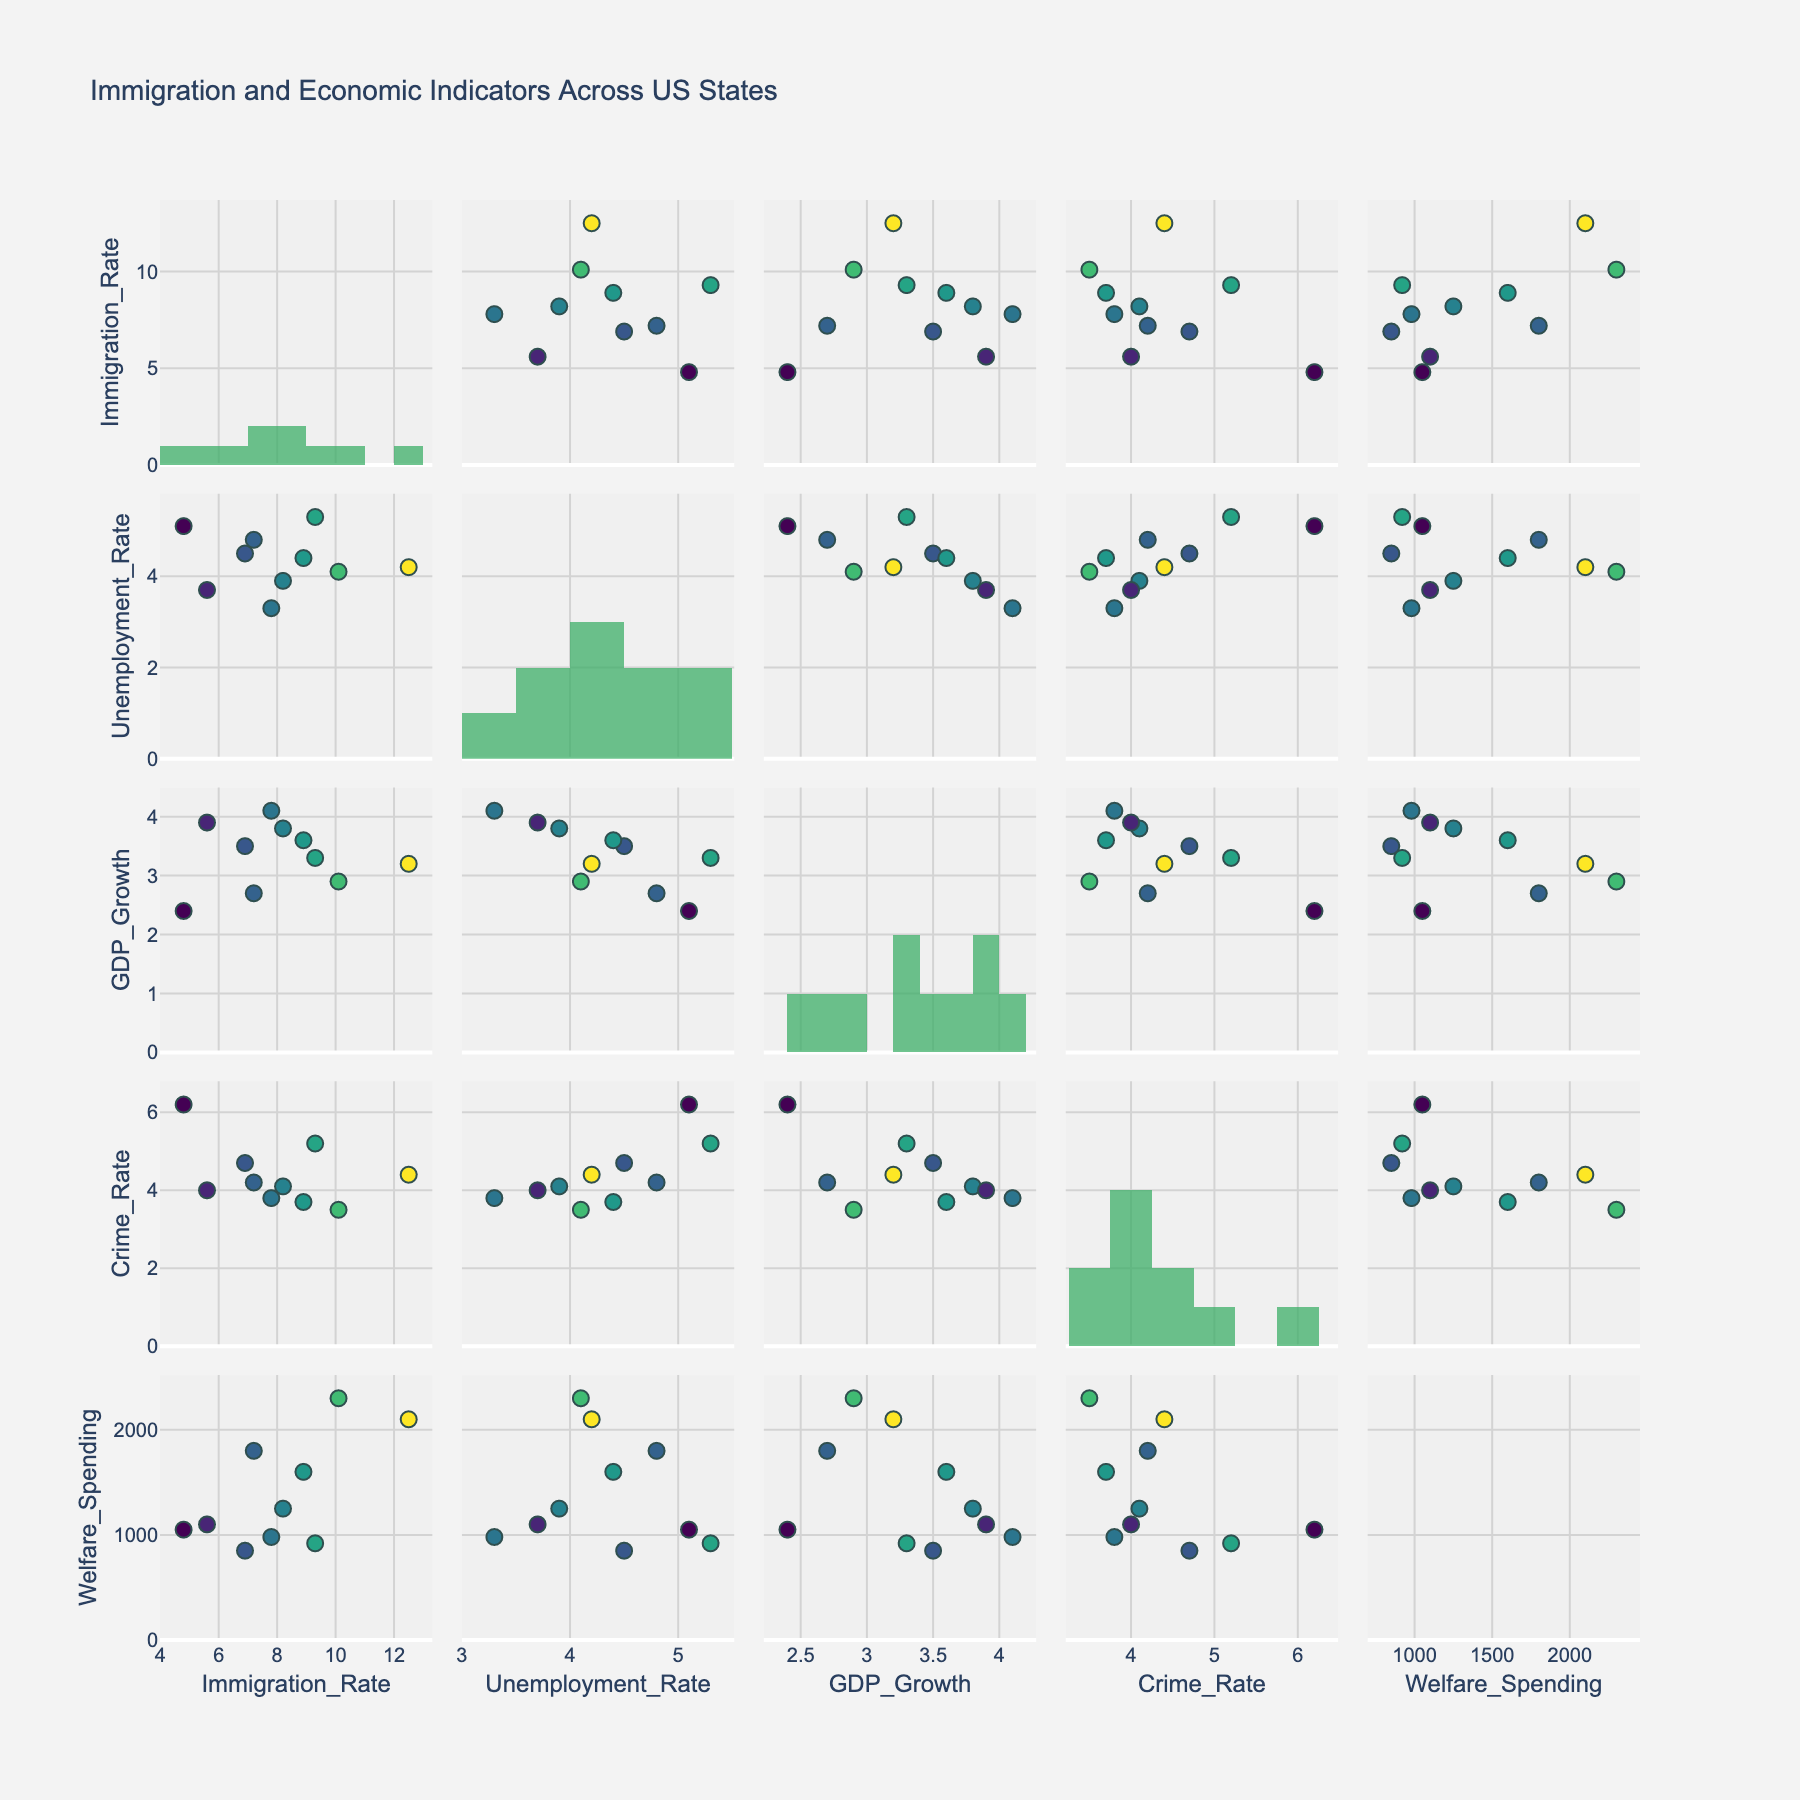What is the title of the figure? The title is displayed at the top of the figure.
Answer: Immigration and Economic Indicators Across US States How many variables are plotted in the scatterplot matrix? The number of rows and columns in the scatterplot matrix indicates the number of variables. There are five rows and five columns.
Answer: 5 Which state has the highest immigration rate? By examining the color intensity of the markers in the scatterplots, we identify California as having the darkest hue, indicating the highest immigration rate.
Answer: California What is the relationship between immigration rate and unemployment rate in states? Look at the scatterplot in the row for Immigration_Rate and the column for Unemployment_Rate. The data points form a visual trend slightly upwards, suggesting a positive correlation.
Answer: Positive correlation Which state has the lowest GDP growth among those with an immigration rate higher than 9%? By filtering for states with immigration rates over 9% (California and Nevada), then checking their GDP growth values in the relevant scatterplots, California has GDP growth of 3.2% and Nevada has 3.3%.
Answer: California What is the average welfare spending of states with immigration rates less than 8%? Filter the states (Florida, Arizona, Georgia, New Mexico, and Illinois) and sum their welfare spending (980+850+1100+1050+1800)=5780. Divide by the number of states (5).
Answer: 1156 Do states with higher unemployment rates tend to have higher crime rates? Inspect the scatterplot for Unemployment_Rate against Crime_Rate. Data points trend upward, which suggests a positive correlation.
Answer: Yes What is the general trend between GDP growth and immigration rate? Look at the scatterplot for GDP_Growth against Immigration_Rate. The points indicate a mixed or slight positive trend, but the correlation is weak.
Answer: Slight positive correlation Are there any states that have both a high crime rate and high immigration rate? Focus on the scatterplot where Immigration_Rate is plotted against Crime_Rate. Nevada and Arizona have higher values for both.
Answer: Nevada and Arizona 